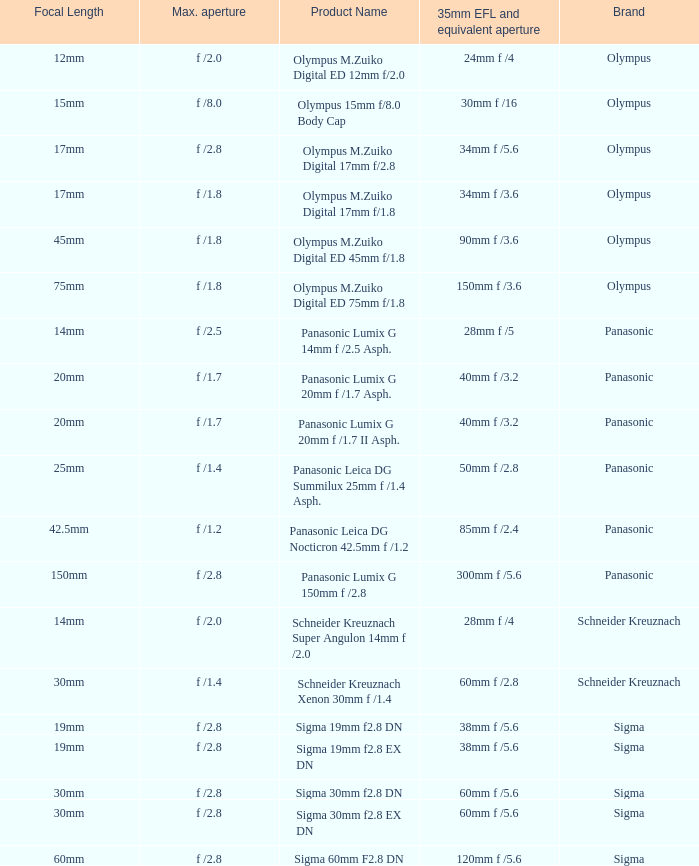What is the brand of the Sigma 30mm f2.8 DN, which has a maximum aperture of f /2.8 and a focal length of 30mm? Sigma. 